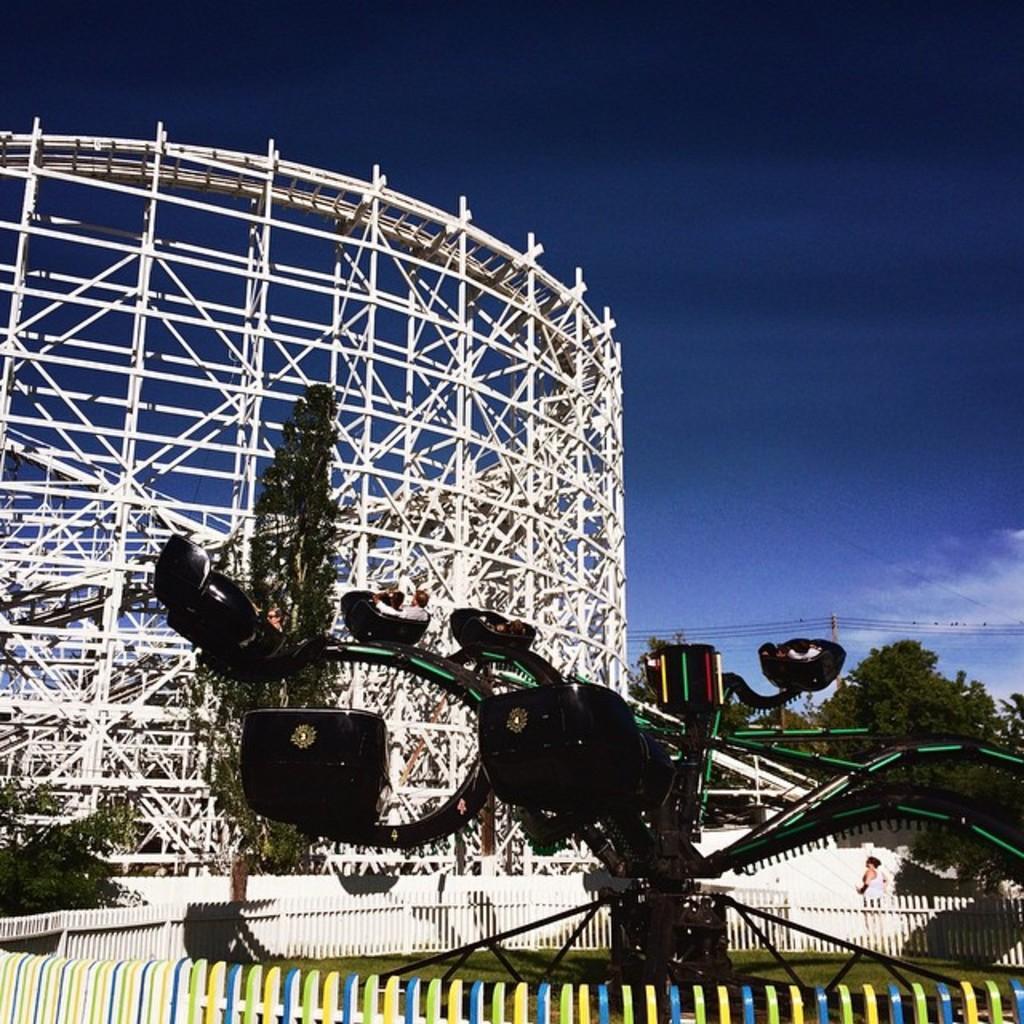Please provide a concise description of this image. In this image we can see a few roller coasters, there are some trees, wires, poles, people and fence, in the background we can see the sky with clouds. 